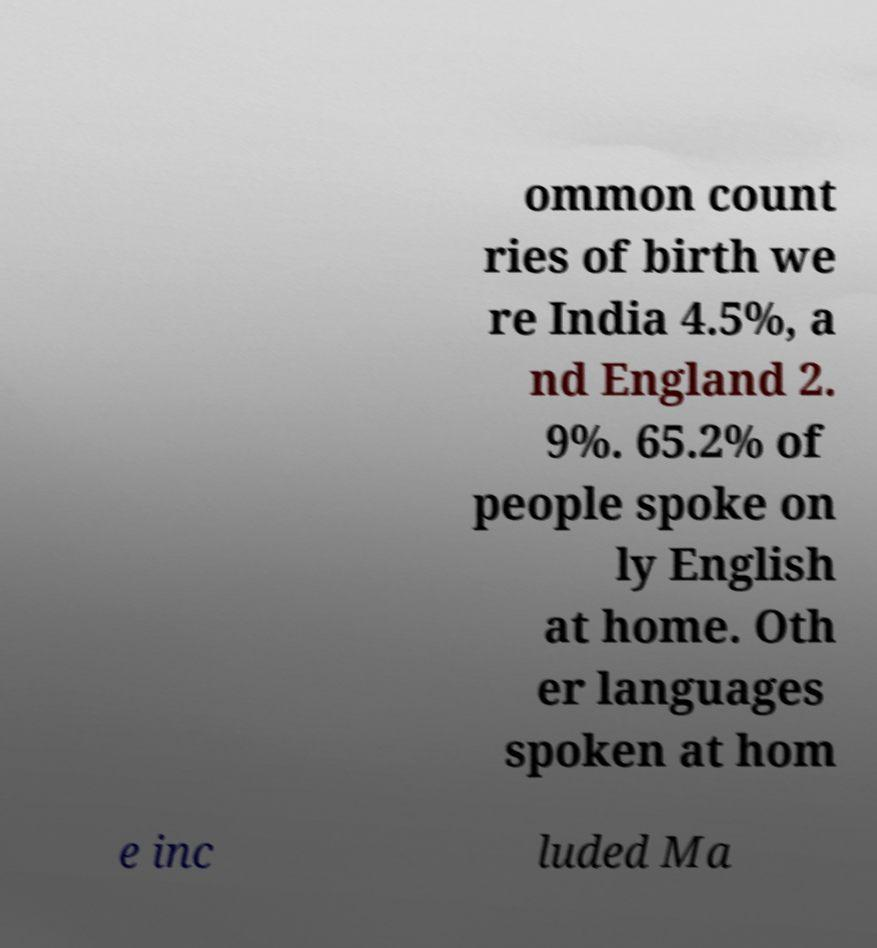Please identify and transcribe the text found in this image. ommon count ries of birth we re India 4.5%, a nd England 2. 9%. 65.2% of people spoke on ly English at home. Oth er languages spoken at hom e inc luded Ma 